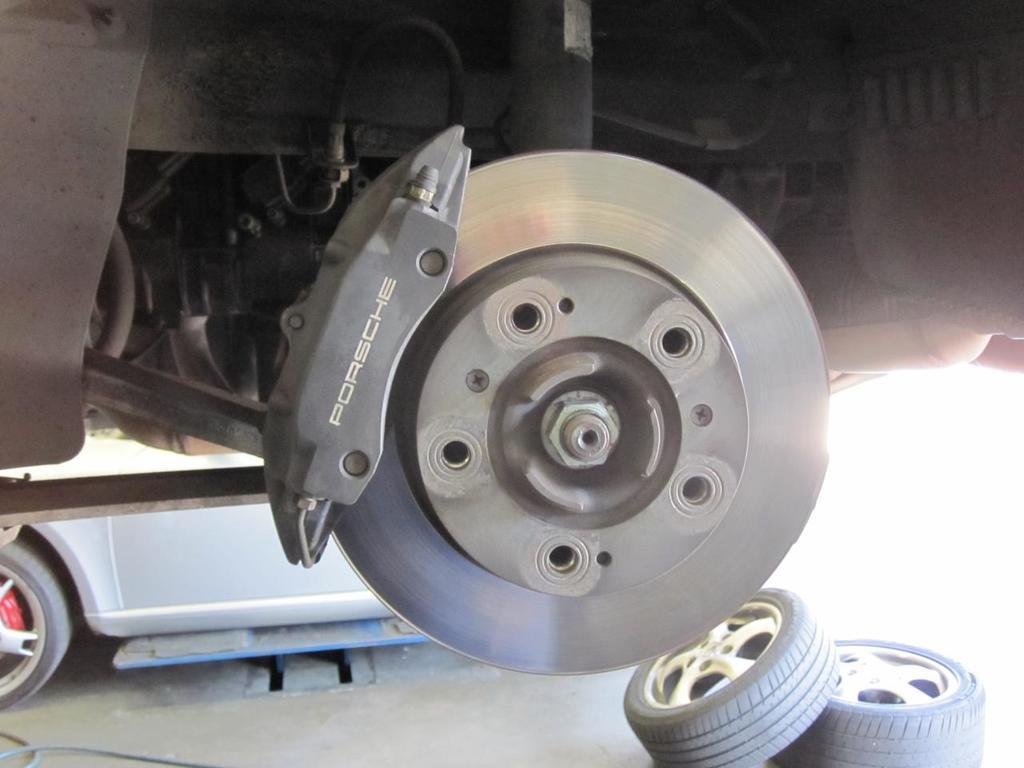Describe this image in one or two sentences. In this image I can see it is the disc brake, at the bottom there are tyres, on the left side it looks like a vehicle. 